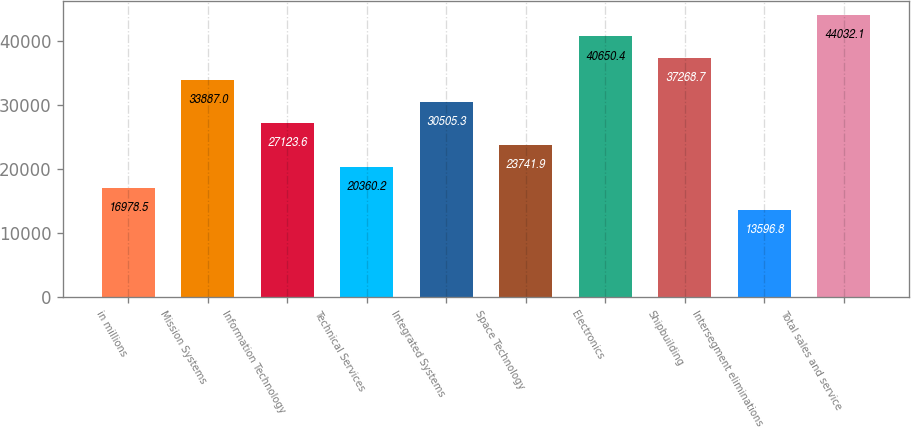Convert chart to OTSL. <chart><loc_0><loc_0><loc_500><loc_500><bar_chart><fcel>in millions<fcel>Mission Systems<fcel>Information Technology<fcel>Technical Services<fcel>Integrated Systems<fcel>Space Technology<fcel>Electronics<fcel>Shipbuilding<fcel>Intersegment eliminations<fcel>Total sales and service<nl><fcel>16978.5<fcel>33887<fcel>27123.6<fcel>20360.2<fcel>30505.3<fcel>23741.9<fcel>40650.4<fcel>37268.7<fcel>13596.8<fcel>44032.1<nl></chart> 